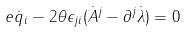<formula> <loc_0><loc_0><loc_500><loc_500>e \dot { q } _ { i } - 2 \theta \epsilon _ { j i } ( \dot { A } ^ { j } - \partial ^ { j } \dot { \lambda } ) = 0</formula> 